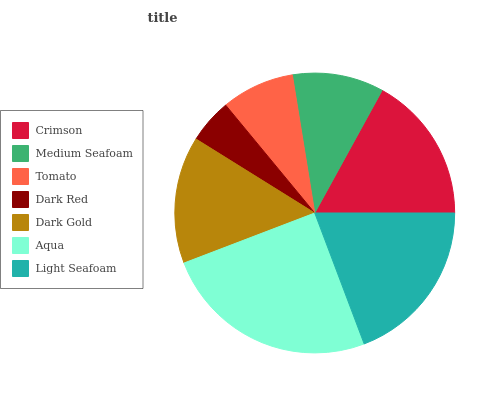Is Dark Red the minimum?
Answer yes or no. Yes. Is Aqua the maximum?
Answer yes or no. Yes. Is Medium Seafoam the minimum?
Answer yes or no. No. Is Medium Seafoam the maximum?
Answer yes or no. No. Is Crimson greater than Medium Seafoam?
Answer yes or no. Yes. Is Medium Seafoam less than Crimson?
Answer yes or no. Yes. Is Medium Seafoam greater than Crimson?
Answer yes or no. No. Is Crimson less than Medium Seafoam?
Answer yes or no. No. Is Dark Gold the high median?
Answer yes or no. Yes. Is Dark Gold the low median?
Answer yes or no. Yes. Is Medium Seafoam the high median?
Answer yes or no. No. Is Crimson the low median?
Answer yes or no. No. 